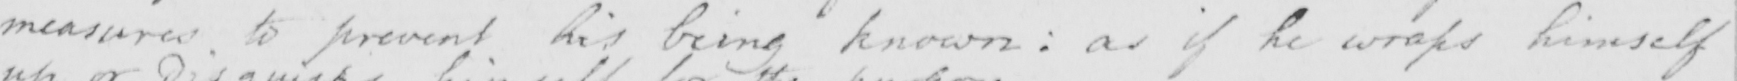Please provide the text content of this handwritten line. measures to prevent his being known :  as if he wraps himself 